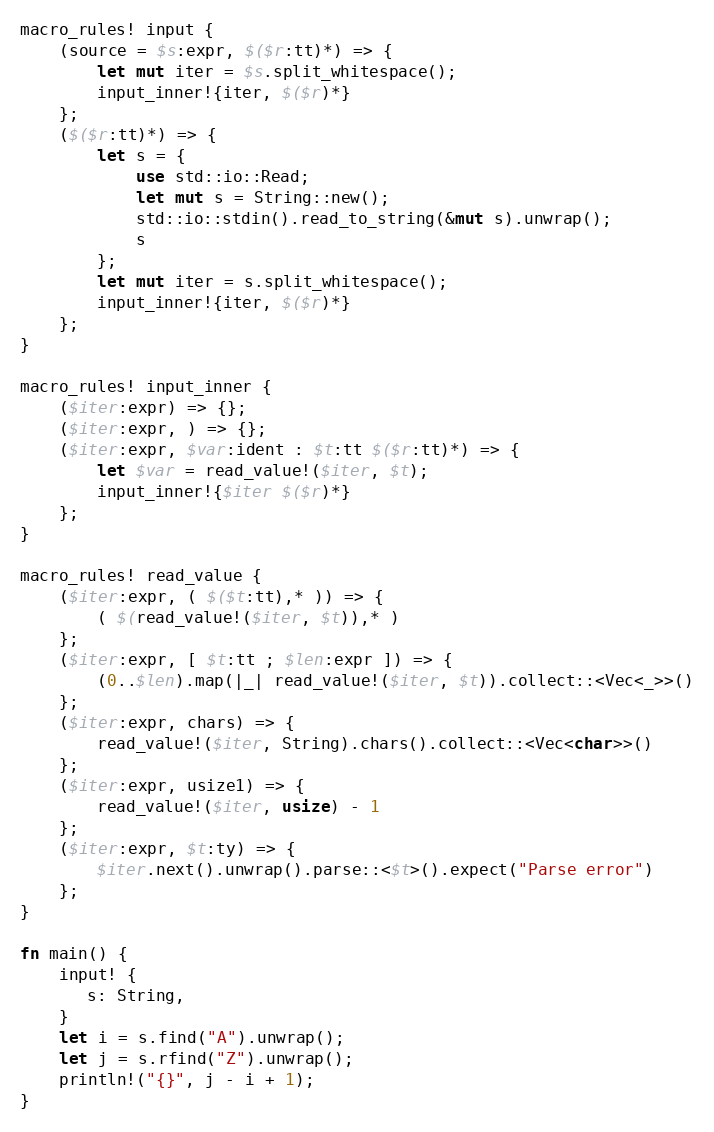<code> <loc_0><loc_0><loc_500><loc_500><_Rust_>macro_rules! input {
    (source = $s:expr, $($r:tt)*) => {
        let mut iter = $s.split_whitespace();
        input_inner!{iter, $($r)*}
    };
    ($($r:tt)*) => {
        let s = {
            use std::io::Read;
            let mut s = String::new();
            std::io::stdin().read_to_string(&mut s).unwrap();
            s
        };
        let mut iter = s.split_whitespace();
        input_inner!{iter, $($r)*}
    };
}

macro_rules! input_inner {
    ($iter:expr) => {};
    ($iter:expr, ) => {};
    ($iter:expr, $var:ident : $t:tt $($r:tt)*) => {
        let $var = read_value!($iter, $t);
        input_inner!{$iter $($r)*}
    };
}

macro_rules! read_value {
    ($iter:expr, ( $($t:tt),* )) => {
        ( $(read_value!($iter, $t)),* )
    };
    ($iter:expr, [ $t:tt ; $len:expr ]) => {
        (0..$len).map(|_| read_value!($iter, $t)).collect::<Vec<_>>()
    };
    ($iter:expr, chars) => {
        read_value!($iter, String).chars().collect::<Vec<char>>()
    };
    ($iter:expr, usize1) => {
        read_value!($iter, usize) - 1
    };
    ($iter:expr, $t:ty) => {
        $iter.next().unwrap().parse::<$t>().expect("Parse error")
    };
}

fn main() {
    input! {
       s: String,
    }
    let i = s.find("A").unwrap();
    let j = s.rfind("Z").unwrap();
    println!("{}", j - i + 1);
}
</code> 